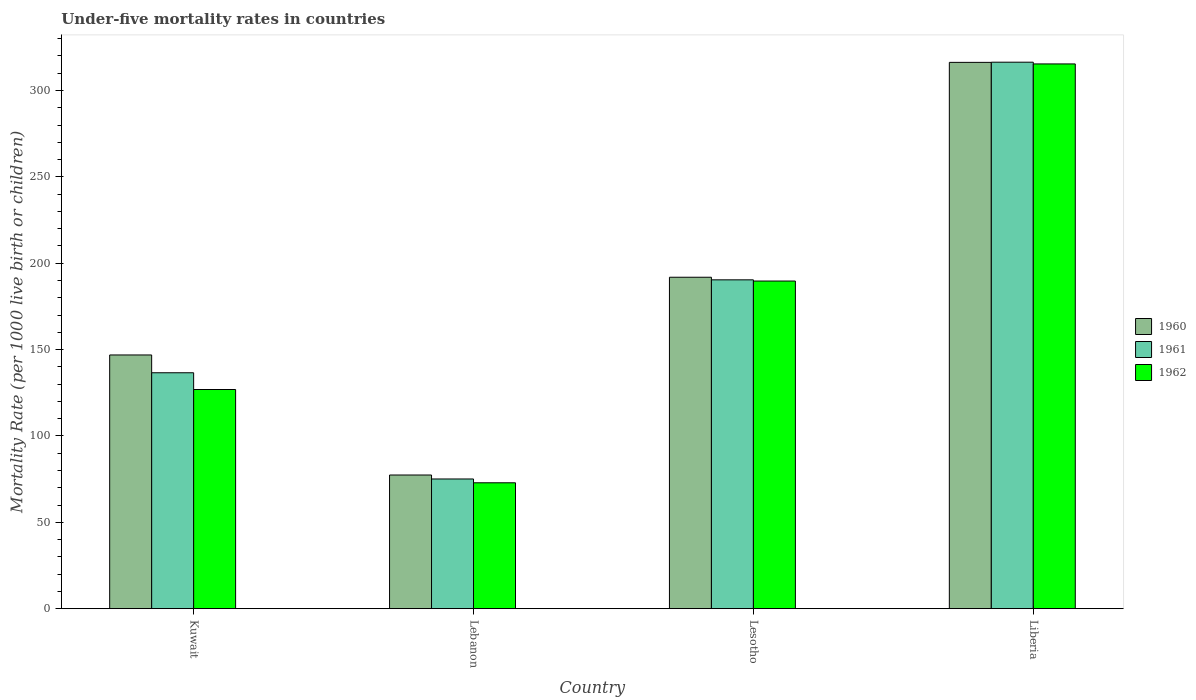How many different coloured bars are there?
Your answer should be compact. 3. Are the number of bars on each tick of the X-axis equal?
Your answer should be very brief. Yes. How many bars are there on the 4th tick from the left?
Make the answer very short. 3. What is the label of the 3rd group of bars from the left?
Your response must be concise. Lesotho. What is the under-five mortality rate in 1960 in Lebanon?
Ensure brevity in your answer.  77.4. Across all countries, what is the maximum under-five mortality rate in 1960?
Provide a succinct answer. 316.3. Across all countries, what is the minimum under-five mortality rate in 1961?
Provide a succinct answer. 75.1. In which country was the under-five mortality rate in 1962 maximum?
Offer a terse response. Liberia. In which country was the under-five mortality rate in 1961 minimum?
Make the answer very short. Lebanon. What is the total under-five mortality rate in 1961 in the graph?
Make the answer very short. 718.5. What is the difference between the under-five mortality rate in 1961 in Lebanon and that in Liberia?
Your answer should be compact. -241.3. What is the difference between the under-five mortality rate in 1960 in Kuwait and the under-five mortality rate in 1962 in Lesotho?
Make the answer very short. -42.8. What is the average under-five mortality rate in 1962 per country?
Offer a very short reply. 176.22. What is the difference between the under-five mortality rate of/in 1960 and under-five mortality rate of/in 1961 in Lesotho?
Offer a very short reply. 1.5. In how many countries, is the under-five mortality rate in 1961 greater than 30?
Give a very brief answer. 4. What is the ratio of the under-five mortality rate in 1962 in Kuwait to that in Lesotho?
Give a very brief answer. 0.67. Is the under-five mortality rate in 1960 in Kuwait less than that in Lebanon?
Offer a terse response. No. Is the difference between the under-five mortality rate in 1960 in Lebanon and Lesotho greater than the difference between the under-five mortality rate in 1961 in Lebanon and Lesotho?
Make the answer very short. Yes. What is the difference between the highest and the second highest under-five mortality rate in 1961?
Offer a terse response. -179.8. What is the difference between the highest and the lowest under-five mortality rate in 1960?
Your answer should be very brief. 238.9. Is the sum of the under-five mortality rate in 1960 in Lebanon and Liberia greater than the maximum under-five mortality rate in 1962 across all countries?
Offer a terse response. Yes. What does the 3rd bar from the right in Lesotho represents?
Your answer should be very brief. 1960. How many bars are there?
Your response must be concise. 12. What is the difference between two consecutive major ticks on the Y-axis?
Give a very brief answer. 50. Are the values on the major ticks of Y-axis written in scientific E-notation?
Ensure brevity in your answer.  No. Does the graph contain grids?
Your answer should be very brief. No. How many legend labels are there?
Your response must be concise. 3. What is the title of the graph?
Provide a short and direct response. Under-five mortality rates in countries. Does "1970" appear as one of the legend labels in the graph?
Ensure brevity in your answer.  No. What is the label or title of the Y-axis?
Give a very brief answer. Mortality Rate (per 1000 live birth or children). What is the Mortality Rate (per 1000 live birth or children) in 1960 in Kuwait?
Your response must be concise. 146.9. What is the Mortality Rate (per 1000 live birth or children) of 1961 in Kuwait?
Ensure brevity in your answer.  136.6. What is the Mortality Rate (per 1000 live birth or children) of 1962 in Kuwait?
Give a very brief answer. 126.9. What is the Mortality Rate (per 1000 live birth or children) of 1960 in Lebanon?
Provide a succinct answer. 77.4. What is the Mortality Rate (per 1000 live birth or children) of 1961 in Lebanon?
Provide a succinct answer. 75.1. What is the Mortality Rate (per 1000 live birth or children) in 1962 in Lebanon?
Offer a very short reply. 72.9. What is the Mortality Rate (per 1000 live birth or children) of 1960 in Lesotho?
Provide a short and direct response. 191.9. What is the Mortality Rate (per 1000 live birth or children) in 1961 in Lesotho?
Offer a terse response. 190.4. What is the Mortality Rate (per 1000 live birth or children) of 1962 in Lesotho?
Offer a very short reply. 189.7. What is the Mortality Rate (per 1000 live birth or children) of 1960 in Liberia?
Give a very brief answer. 316.3. What is the Mortality Rate (per 1000 live birth or children) in 1961 in Liberia?
Your answer should be compact. 316.4. What is the Mortality Rate (per 1000 live birth or children) of 1962 in Liberia?
Give a very brief answer. 315.4. Across all countries, what is the maximum Mortality Rate (per 1000 live birth or children) in 1960?
Your answer should be compact. 316.3. Across all countries, what is the maximum Mortality Rate (per 1000 live birth or children) in 1961?
Your answer should be very brief. 316.4. Across all countries, what is the maximum Mortality Rate (per 1000 live birth or children) of 1962?
Provide a short and direct response. 315.4. Across all countries, what is the minimum Mortality Rate (per 1000 live birth or children) in 1960?
Keep it short and to the point. 77.4. Across all countries, what is the minimum Mortality Rate (per 1000 live birth or children) of 1961?
Offer a terse response. 75.1. Across all countries, what is the minimum Mortality Rate (per 1000 live birth or children) in 1962?
Make the answer very short. 72.9. What is the total Mortality Rate (per 1000 live birth or children) in 1960 in the graph?
Provide a succinct answer. 732.5. What is the total Mortality Rate (per 1000 live birth or children) in 1961 in the graph?
Give a very brief answer. 718.5. What is the total Mortality Rate (per 1000 live birth or children) of 1962 in the graph?
Keep it short and to the point. 704.9. What is the difference between the Mortality Rate (per 1000 live birth or children) of 1960 in Kuwait and that in Lebanon?
Make the answer very short. 69.5. What is the difference between the Mortality Rate (per 1000 live birth or children) of 1961 in Kuwait and that in Lebanon?
Give a very brief answer. 61.5. What is the difference between the Mortality Rate (per 1000 live birth or children) in 1960 in Kuwait and that in Lesotho?
Ensure brevity in your answer.  -45. What is the difference between the Mortality Rate (per 1000 live birth or children) of 1961 in Kuwait and that in Lesotho?
Your response must be concise. -53.8. What is the difference between the Mortality Rate (per 1000 live birth or children) of 1962 in Kuwait and that in Lesotho?
Offer a terse response. -62.8. What is the difference between the Mortality Rate (per 1000 live birth or children) of 1960 in Kuwait and that in Liberia?
Your answer should be very brief. -169.4. What is the difference between the Mortality Rate (per 1000 live birth or children) of 1961 in Kuwait and that in Liberia?
Provide a succinct answer. -179.8. What is the difference between the Mortality Rate (per 1000 live birth or children) of 1962 in Kuwait and that in Liberia?
Your answer should be very brief. -188.5. What is the difference between the Mortality Rate (per 1000 live birth or children) in 1960 in Lebanon and that in Lesotho?
Your answer should be very brief. -114.5. What is the difference between the Mortality Rate (per 1000 live birth or children) of 1961 in Lebanon and that in Lesotho?
Ensure brevity in your answer.  -115.3. What is the difference between the Mortality Rate (per 1000 live birth or children) of 1962 in Lebanon and that in Lesotho?
Provide a short and direct response. -116.8. What is the difference between the Mortality Rate (per 1000 live birth or children) of 1960 in Lebanon and that in Liberia?
Your answer should be very brief. -238.9. What is the difference between the Mortality Rate (per 1000 live birth or children) in 1961 in Lebanon and that in Liberia?
Provide a succinct answer. -241.3. What is the difference between the Mortality Rate (per 1000 live birth or children) in 1962 in Lebanon and that in Liberia?
Keep it short and to the point. -242.5. What is the difference between the Mortality Rate (per 1000 live birth or children) of 1960 in Lesotho and that in Liberia?
Provide a succinct answer. -124.4. What is the difference between the Mortality Rate (per 1000 live birth or children) of 1961 in Lesotho and that in Liberia?
Provide a succinct answer. -126. What is the difference between the Mortality Rate (per 1000 live birth or children) in 1962 in Lesotho and that in Liberia?
Your response must be concise. -125.7. What is the difference between the Mortality Rate (per 1000 live birth or children) in 1960 in Kuwait and the Mortality Rate (per 1000 live birth or children) in 1961 in Lebanon?
Ensure brevity in your answer.  71.8. What is the difference between the Mortality Rate (per 1000 live birth or children) of 1961 in Kuwait and the Mortality Rate (per 1000 live birth or children) of 1962 in Lebanon?
Provide a short and direct response. 63.7. What is the difference between the Mortality Rate (per 1000 live birth or children) of 1960 in Kuwait and the Mortality Rate (per 1000 live birth or children) of 1961 in Lesotho?
Your response must be concise. -43.5. What is the difference between the Mortality Rate (per 1000 live birth or children) of 1960 in Kuwait and the Mortality Rate (per 1000 live birth or children) of 1962 in Lesotho?
Keep it short and to the point. -42.8. What is the difference between the Mortality Rate (per 1000 live birth or children) in 1961 in Kuwait and the Mortality Rate (per 1000 live birth or children) in 1962 in Lesotho?
Provide a succinct answer. -53.1. What is the difference between the Mortality Rate (per 1000 live birth or children) of 1960 in Kuwait and the Mortality Rate (per 1000 live birth or children) of 1961 in Liberia?
Provide a short and direct response. -169.5. What is the difference between the Mortality Rate (per 1000 live birth or children) of 1960 in Kuwait and the Mortality Rate (per 1000 live birth or children) of 1962 in Liberia?
Your answer should be very brief. -168.5. What is the difference between the Mortality Rate (per 1000 live birth or children) of 1961 in Kuwait and the Mortality Rate (per 1000 live birth or children) of 1962 in Liberia?
Provide a succinct answer. -178.8. What is the difference between the Mortality Rate (per 1000 live birth or children) in 1960 in Lebanon and the Mortality Rate (per 1000 live birth or children) in 1961 in Lesotho?
Provide a succinct answer. -113. What is the difference between the Mortality Rate (per 1000 live birth or children) in 1960 in Lebanon and the Mortality Rate (per 1000 live birth or children) in 1962 in Lesotho?
Your answer should be compact. -112.3. What is the difference between the Mortality Rate (per 1000 live birth or children) in 1961 in Lebanon and the Mortality Rate (per 1000 live birth or children) in 1962 in Lesotho?
Your answer should be very brief. -114.6. What is the difference between the Mortality Rate (per 1000 live birth or children) in 1960 in Lebanon and the Mortality Rate (per 1000 live birth or children) in 1961 in Liberia?
Keep it short and to the point. -239. What is the difference between the Mortality Rate (per 1000 live birth or children) of 1960 in Lebanon and the Mortality Rate (per 1000 live birth or children) of 1962 in Liberia?
Make the answer very short. -238. What is the difference between the Mortality Rate (per 1000 live birth or children) in 1961 in Lebanon and the Mortality Rate (per 1000 live birth or children) in 1962 in Liberia?
Keep it short and to the point. -240.3. What is the difference between the Mortality Rate (per 1000 live birth or children) of 1960 in Lesotho and the Mortality Rate (per 1000 live birth or children) of 1961 in Liberia?
Your answer should be compact. -124.5. What is the difference between the Mortality Rate (per 1000 live birth or children) in 1960 in Lesotho and the Mortality Rate (per 1000 live birth or children) in 1962 in Liberia?
Ensure brevity in your answer.  -123.5. What is the difference between the Mortality Rate (per 1000 live birth or children) of 1961 in Lesotho and the Mortality Rate (per 1000 live birth or children) of 1962 in Liberia?
Ensure brevity in your answer.  -125. What is the average Mortality Rate (per 1000 live birth or children) of 1960 per country?
Offer a terse response. 183.12. What is the average Mortality Rate (per 1000 live birth or children) in 1961 per country?
Ensure brevity in your answer.  179.62. What is the average Mortality Rate (per 1000 live birth or children) of 1962 per country?
Give a very brief answer. 176.22. What is the difference between the Mortality Rate (per 1000 live birth or children) of 1961 and Mortality Rate (per 1000 live birth or children) of 1962 in Kuwait?
Provide a short and direct response. 9.7. What is the difference between the Mortality Rate (per 1000 live birth or children) of 1960 and Mortality Rate (per 1000 live birth or children) of 1961 in Lebanon?
Keep it short and to the point. 2.3. What is the difference between the Mortality Rate (per 1000 live birth or children) of 1960 and Mortality Rate (per 1000 live birth or children) of 1962 in Lebanon?
Offer a very short reply. 4.5. What is the difference between the Mortality Rate (per 1000 live birth or children) of 1960 and Mortality Rate (per 1000 live birth or children) of 1961 in Lesotho?
Your response must be concise. 1.5. What is the difference between the Mortality Rate (per 1000 live birth or children) of 1960 and Mortality Rate (per 1000 live birth or children) of 1961 in Liberia?
Provide a short and direct response. -0.1. What is the difference between the Mortality Rate (per 1000 live birth or children) of 1961 and Mortality Rate (per 1000 live birth or children) of 1962 in Liberia?
Provide a succinct answer. 1. What is the ratio of the Mortality Rate (per 1000 live birth or children) of 1960 in Kuwait to that in Lebanon?
Make the answer very short. 1.9. What is the ratio of the Mortality Rate (per 1000 live birth or children) of 1961 in Kuwait to that in Lebanon?
Give a very brief answer. 1.82. What is the ratio of the Mortality Rate (per 1000 live birth or children) in 1962 in Kuwait to that in Lebanon?
Make the answer very short. 1.74. What is the ratio of the Mortality Rate (per 1000 live birth or children) in 1960 in Kuwait to that in Lesotho?
Your response must be concise. 0.77. What is the ratio of the Mortality Rate (per 1000 live birth or children) of 1961 in Kuwait to that in Lesotho?
Provide a short and direct response. 0.72. What is the ratio of the Mortality Rate (per 1000 live birth or children) in 1962 in Kuwait to that in Lesotho?
Offer a terse response. 0.67. What is the ratio of the Mortality Rate (per 1000 live birth or children) of 1960 in Kuwait to that in Liberia?
Offer a terse response. 0.46. What is the ratio of the Mortality Rate (per 1000 live birth or children) in 1961 in Kuwait to that in Liberia?
Offer a very short reply. 0.43. What is the ratio of the Mortality Rate (per 1000 live birth or children) in 1962 in Kuwait to that in Liberia?
Give a very brief answer. 0.4. What is the ratio of the Mortality Rate (per 1000 live birth or children) of 1960 in Lebanon to that in Lesotho?
Make the answer very short. 0.4. What is the ratio of the Mortality Rate (per 1000 live birth or children) of 1961 in Lebanon to that in Lesotho?
Your answer should be compact. 0.39. What is the ratio of the Mortality Rate (per 1000 live birth or children) of 1962 in Lebanon to that in Lesotho?
Provide a short and direct response. 0.38. What is the ratio of the Mortality Rate (per 1000 live birth or children) in 1960 in Lebanon to that in Liberia?
Your answer should be very brief. 0.24. What is the ratio of the Mortality Rate (per 1000 live birth or children) of 1961 in Lebanon to that in Liberia?
Your answer should be compact. 0.24. What is the ratio of the Mortality Rate (per 1000 live birth or children) of 1962 in Lebanon to that in Liberia?
Keep it short and to the point. 0.23. What is the ratio of the Mortality Rate (per 1000 live birth or children) of 1960 in Lesotho to that in Liberia?
Provide a succinct answer. 0.61. What is the ratio of the Mortality Rate (per 1000 live birth or children) in 1961 in Lesotho to that in Liberia?
Give a very brief answer. 0.6. What is the ratio of the Mortality Rate (per 1000 live birth or children) of 1962 in Lesotho to that in Liberia?
Provide a short and direct response. 0.6. What is the difference between the highest and the second highest Mortality Rate (per 1000 live birth or children) in 1960?
Ensure brevity in your answer.  124.4. What is the difference between the highest and the second highest Mortality Rate (per 1000 live birth or children) of 1961?
Make the answer very short. 126. What is the difference between the highest and the second highest Mortality Rate (per 1000 live birth or children) of 1962?
Your answer should be very brief. 125.7. What is the difference between the highest and the lowest Mortality Rate (per 1000 live birth or children) of 1960?
Provide a succinct answer. 238.9. What is the difference between the highest and the lowest Mortality Rate (per 1000 live birth or children) of 1961?
Your response must be concise. 241.3. What is the difference between the highest and the lowest Mortality Rate (per 1000 live birth or children) in 1962?
Your response must be concise. 242.5. 